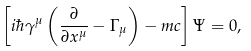Convert formula to latex. <formula><loc_0><loc_0><loc_500><loc_500>\left [ i \hbar { \gamma } ^ { \mu } \left ( \frac { \partial } { \partial x ^ { \mu } } - \Gamma _ { \mu } \right ) - m c \right ] \Psi = 0 ,</formula> 